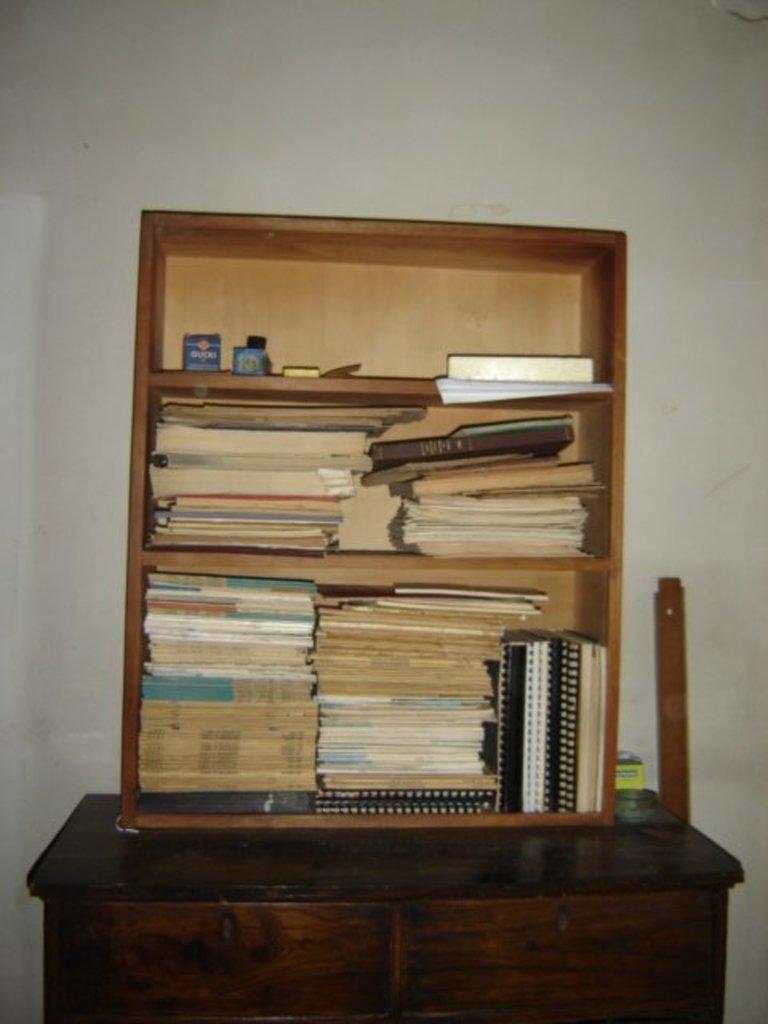Please provide a concise description of this image. In this picture we can see a rack here, there are some books on the rack, at the bottom there is a table, we can see a wall in the background. 